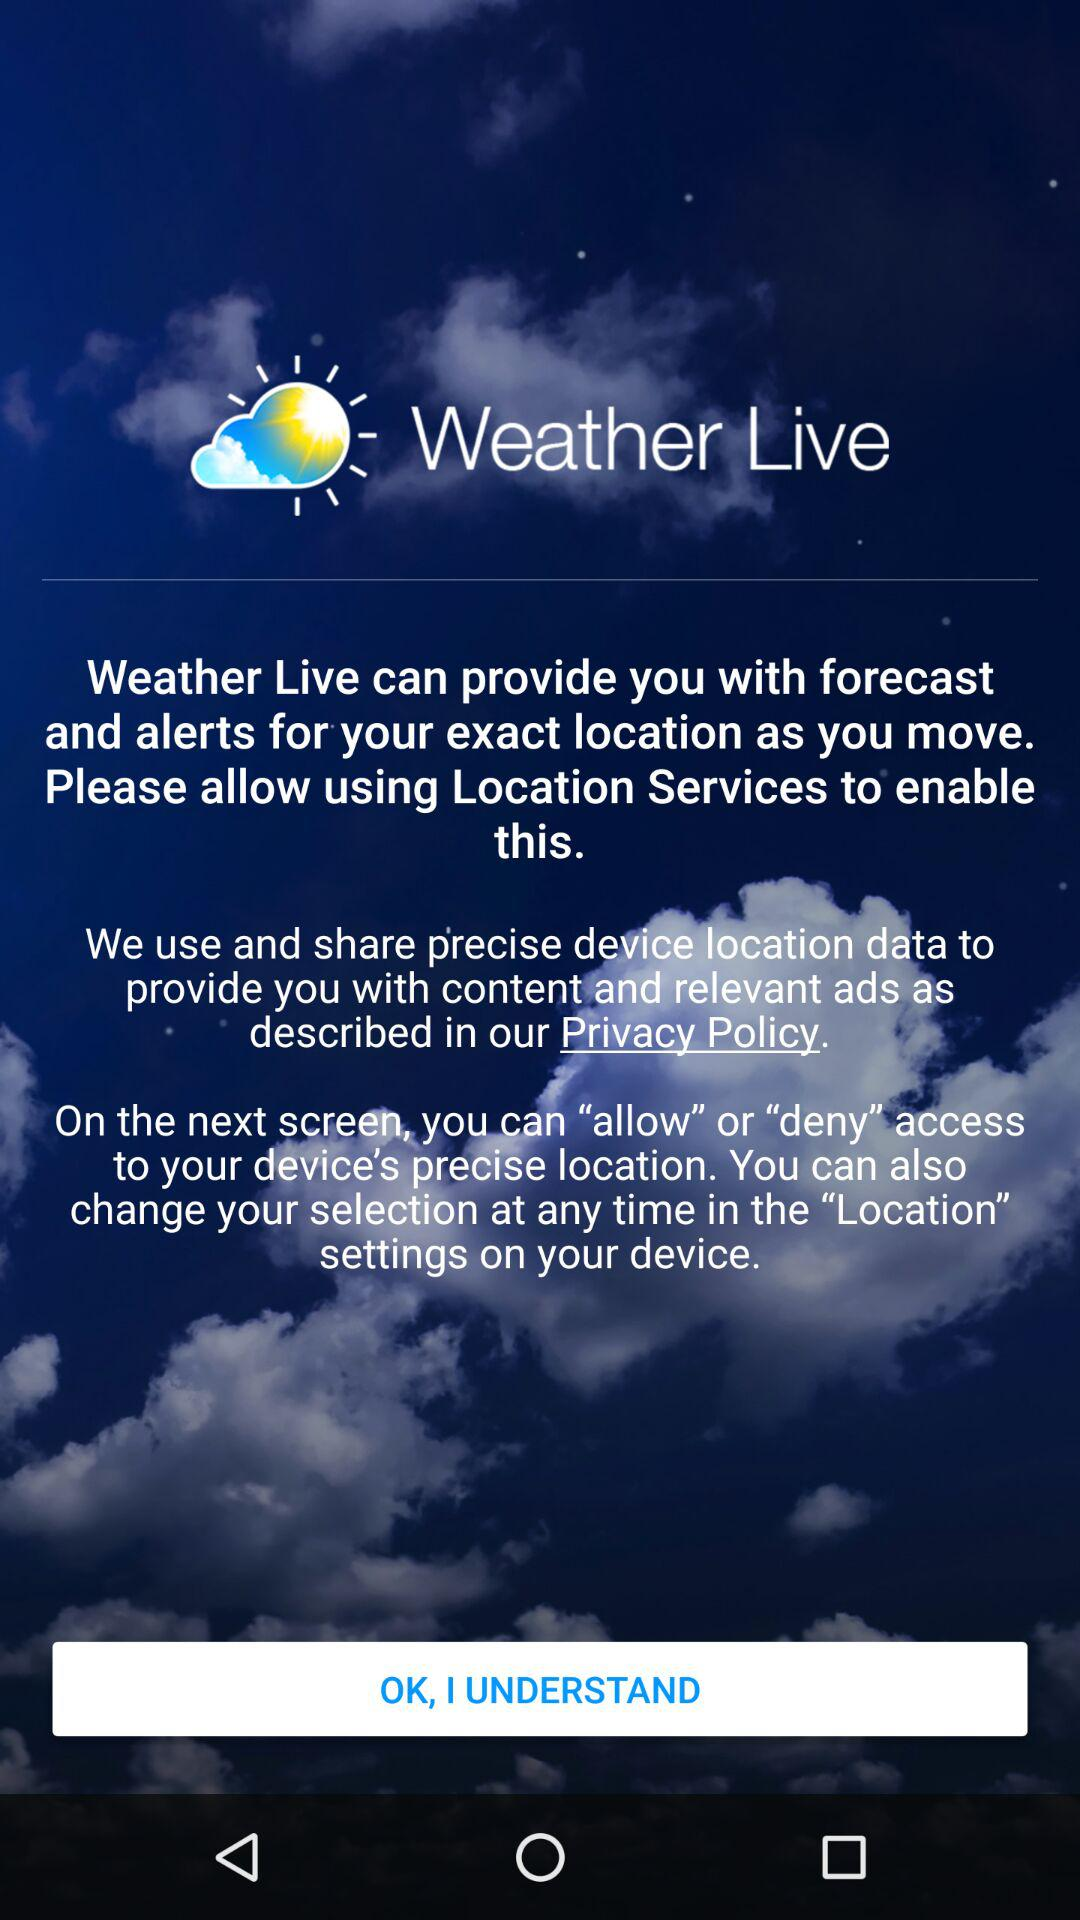What is the app name? The app name is "Weather Live". 